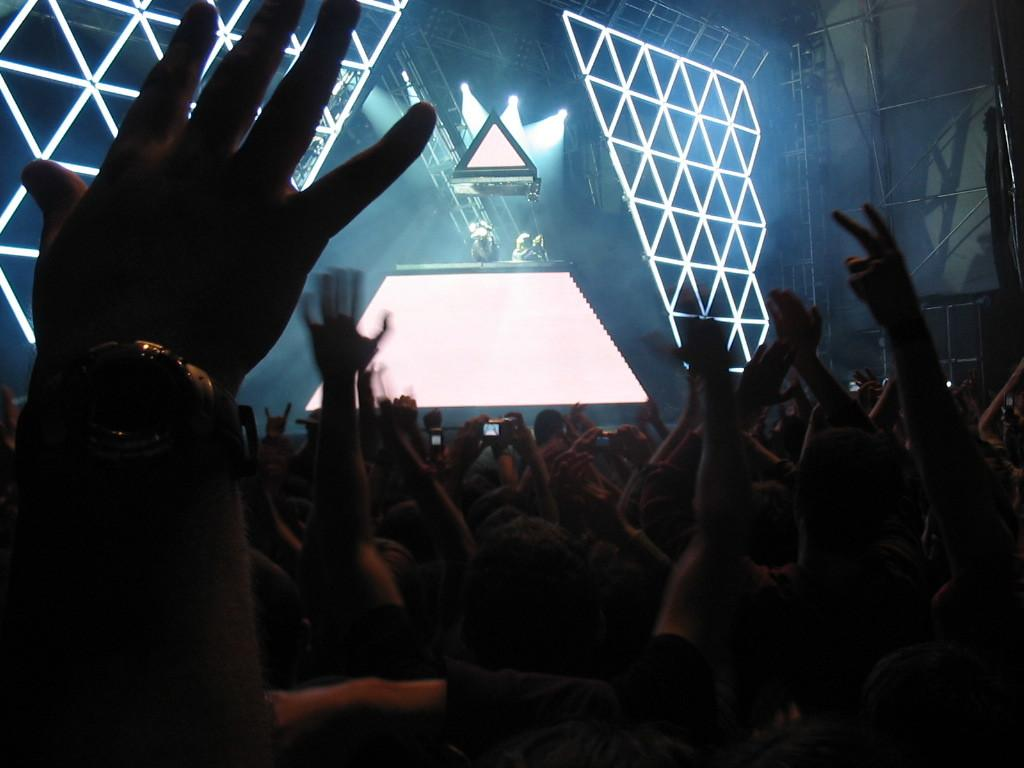How many people are in the image? There are multiple persons in the image. What are some of the persons doing in the image? Some of the persons are clicking pictures. What can be seen at the top of the image? There are lights visible at the top of the image. What type of mint is being used to freshen the breath of the persons in the image? There is no mention of mint or breath freshening in the image. What time of day is it in the image? The provided facts do not give any information about the time of day. 